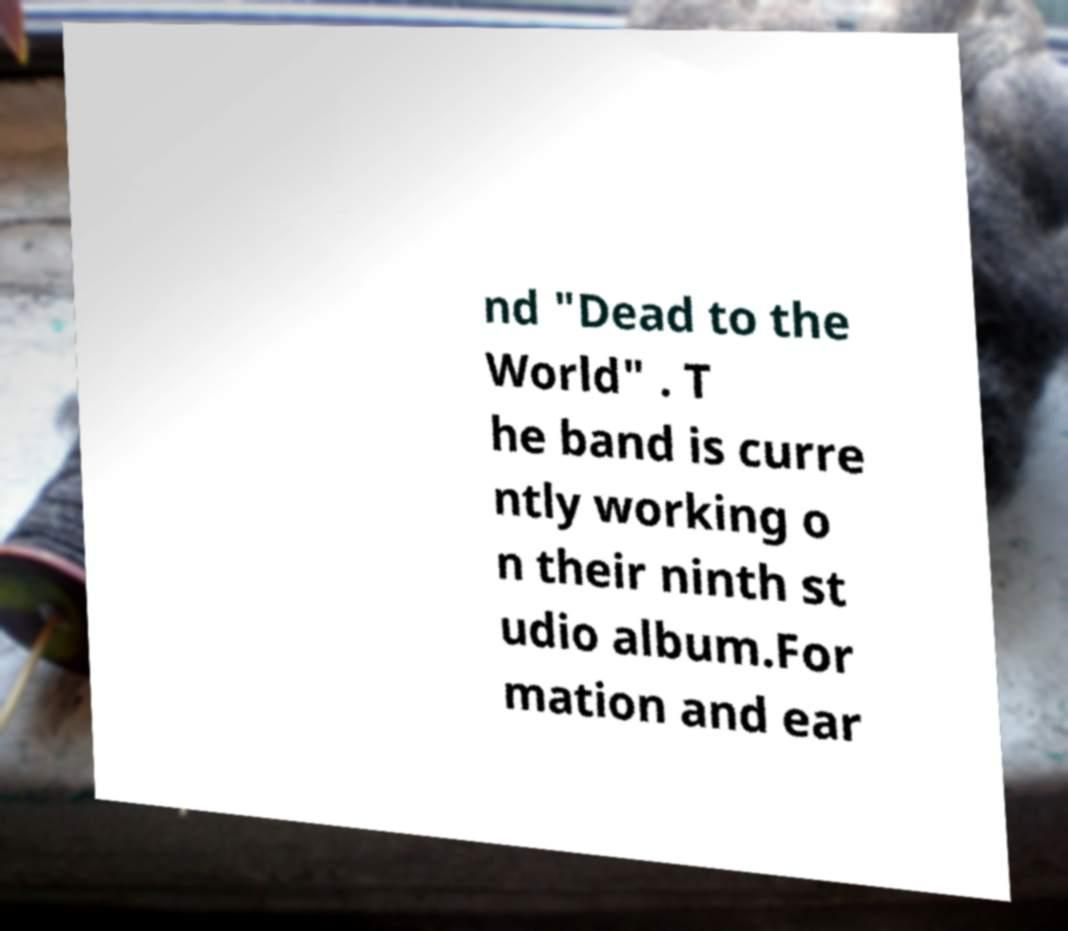Please identify and transcribe the text found in this image. nd "Dead to the World" . T he band is curre ntly working o n their ninth st udio album.For mation and ear 